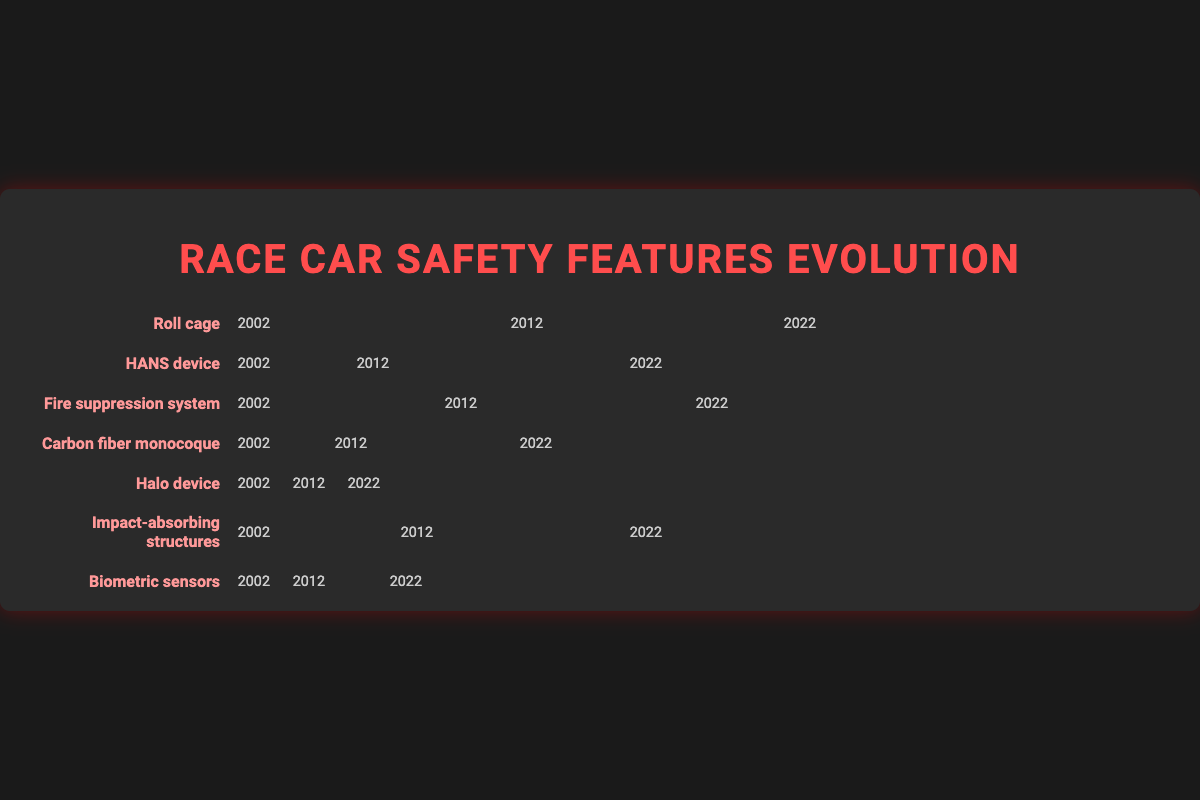What is the title of the Isotype Plot? The title of the plot is displayed at the top-center of the figure, typically in larger font size and distinct color.
Answer: Race Car Safety Features Evolution Which safety feature had a consistent high frequency from 2002 to 2022? By observing the rows and the icons, the Roll cage has 10 icons consistently across the years 2002, 2012, and 2022, indicating its stable high frequency.
Answer: Roll cage How many safety features were introduced after 2002? Identify the safety features with a frequency of 0 in 2002 and a non-zero frequency in subsequent years. The Halo device and Biometric sensors fit this criterion.
Answer: 2 Which safety feature showed the most significant increase from 2002 to 2022? Calculate the difference in the number of icons for each feature between 2002 and 2022. The feature with the highest difference is the HANS device (10 - 3 = 7).
Answer: HANS device Compare the frequency of "Carbon fiber monocoque" and "Halo device" in 2022. Which one is higher? Count the number of icons for both features in 2022. Carbon fiber monocoque has 9, while Halo device has 8.
Answer: Carbon fiber monocoque Which year had the highest overall implementation of "Fire suppression system"? Count the number of icons for the Fire suppression system in 2002, 2012, and 2022. The count for 2022 is the highest at 10.
Answer: 2022 What is the total frequency of all safety features implemented in 2012? Add the number of icons for each feature in 2012: 10 (Roll cage) + 10 (HANS device) + 9 (Fire suppression system) + 6 (Carbon fiber monocoque) + 0 (Halo device) + 8 (Impact-absorbing structures) + 2 (Biometric sensors) = 45.
Answer: 45 What trend can be observed for the "Impact-absorbing structures" from 2002 to 2022? Look at the number of icons for Impact-absorbing structures across the three years: it increases from 5 (2002) to 8 (2012) and then to 10 (2022). This shows a trend of increasing implementation.
Answer: Increasing How does the frequency of new safety features (Halo device & Biometric sensors) in 2022 compare to traditional ones (Roll cage & Fire suppression system)? The new features introduced after 2002 (Halo device and Biometric sensors) have 8 and 7 icons respectively in 2022. The traditional features (Roll cage and Fire suppression system) each have 10 icons.
Answer: Traditional features have higher frequency 